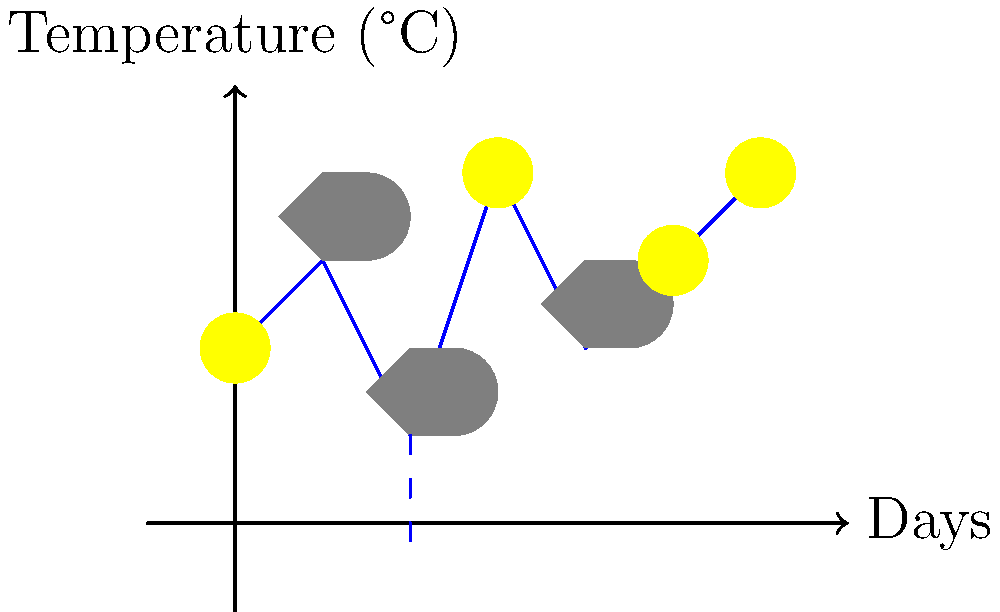As a city-dweller planning a weekend farm visit, you're studying the weather forecast for the upcoming week. Based on the chart showing temperature trends and weather symbols, on which day would you expect the best conditions for outdoor farm activities? Let's analyze the chart day by day:

1. Day 0: Sunny, but relatively cool (2°C)
2. Day 1: Cloudy and slightly warmer (3°C)
3. Day 2: Rainy and cold (1°C)
4. Day 3: Sunny and warmest (4°C)
5. Day 4: Cloudy and cooler (2°C)
6. Day 5: Sunny and warm (3°C)
7. Day 6: Sunny and warmest (4°C)

For outdoor farm activities, we typically want a day that is:
1. Sunny (for good visibility and pleasant conditions)
2. Warm (for comfort while working outdoors)
3. Not rainy (to avoid muddy conditions and allow for dry outdoor work)

Based on these criteria, we can eliminate days 1, 2, and 4 due to cloud cover or rain. Among the sunny days (0, 3, 5, and 6), we should choose the warmest for the most comfortable experience.

Day 6 stands out as the best option because it's sunny and tied for the warmest temperature (4°C) with Day 3. However, Day 6 is preferable as it comes after a series of warmer days, suggesting more stable warm conditions compared to Day 3, which follows a rainy, cold day.
Answer: Day 6 